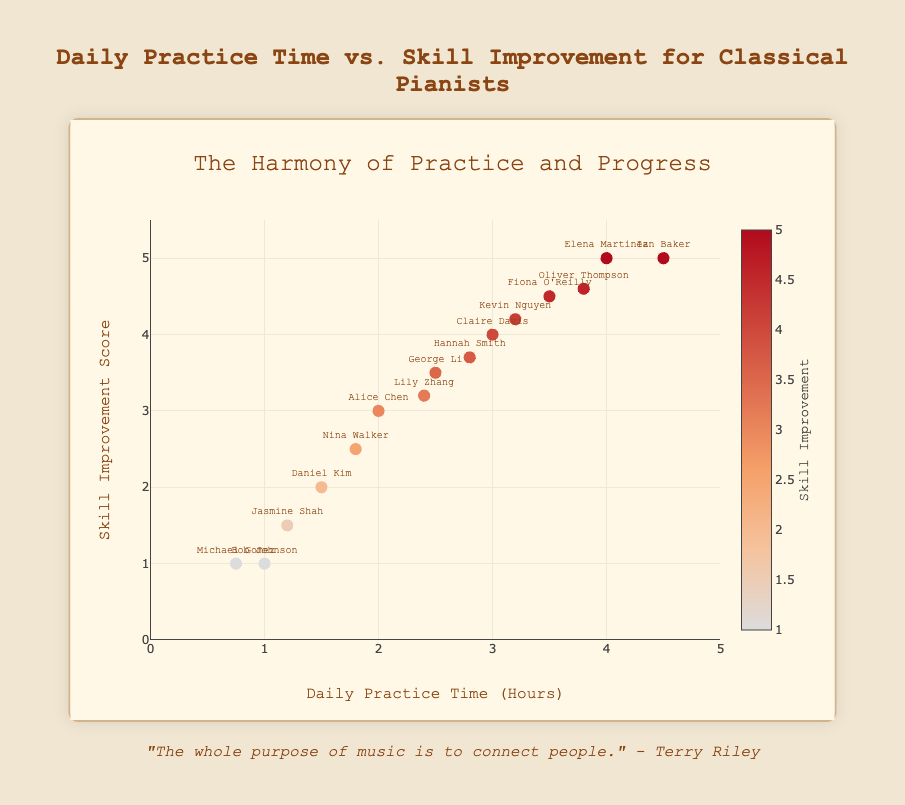What is the relationship between daily practice time and skill improvement? By examining the overall trend in the scatter plot, you can see that as daily practice time increases, the skill improvement score tends to increase as well. This indicates a positive correlation between the two variables.
Answer: Positive correlation Which pianist has the highest daily practice time, and what is their skill improvement score? Looking at the scatter plot's x-axis, the point furthest to the right represents Ian Baker, who practices for 4.5 hours daily. His skill improvement score, indicated on the y-axis, is 5.
Answer: Ian Baker with a score of 5 How many pianists practice more than 3 hours daily? By counting the points located to the right of the 3-hour mark on the x-axis, we can identify five pianists who practice more than 3 hours daily: Elena Martinez, Fiona O'Reilly, Oliver Thompson, Kevin Nguyen, and Ian Baker.
Answer: 5 What is the average skill improvement score for pianists who practice less than 2 hours daily? The pianists in this category are Bob Johnson (1), Daniel Kim (2), Jasmine Shah (1.5), Michael Gomez (1), Nina Walker (2.5). Sum their scores (1 + 2 + 1.5 + 1 + 2.5 = 8) and divide by the number of pianists (8/5).
Answer: 1.6 Compare the skill improvement scores for Alice Chen and George Li. Who has a higher score? Alice Chen's daily practice time is 2 hours with a skill improvement score of 3. George Li practices 2.5 hours with a skill improvement score of 3.5. Thus, George Li has a higher score.
Answer: George Li What is the distribution of pianists achieving the maximum skill improvement score of 5? The pianists with a skill improvement score of 5 are Elena Martinez and Ian Baker. By examining the y-axis, it's clear that two data points reach this maximum score.
Answer: 2 Identify the pianist who practices 3 hours daily and determine their skill improvement score. By finding the point along the x-axis where daily practice time is 3 hours, we identify Claire Davis. The corresponding y-axis value gives a skill improvement score of 4.
Answer: Claire Davis with a score of 4 How does Hannah Smith's practice time compare to Kevin Nguyen's? Hannah Smith practices 2.8 hours daily, while Kevin Nguyen practices 3.2 hours. Hence, Kevin practices more by 0.4 hours daily.
Answer: Kevin Nguyen practices more by 0.4 hours What is the range of daily practice times amongst the pianists? The minimum daily practice time is 0.75 hours (Michael Gomez), and the maximum is 4.5 hours (Ian Baker). The range can be found by subtracting these values (4.5 - 0.75).
Answer: 3.75 hours Which pianist has a skill improvement score of 4.5, and how long do they practice daily? To find the pianist with a skill improvement score of 4.5, locate the corresponding y-value. Fiona O'Reilly, who practices 3.5 hours daily, has this score.
Answer: Fiona O'Reilly, 3.5 hours 